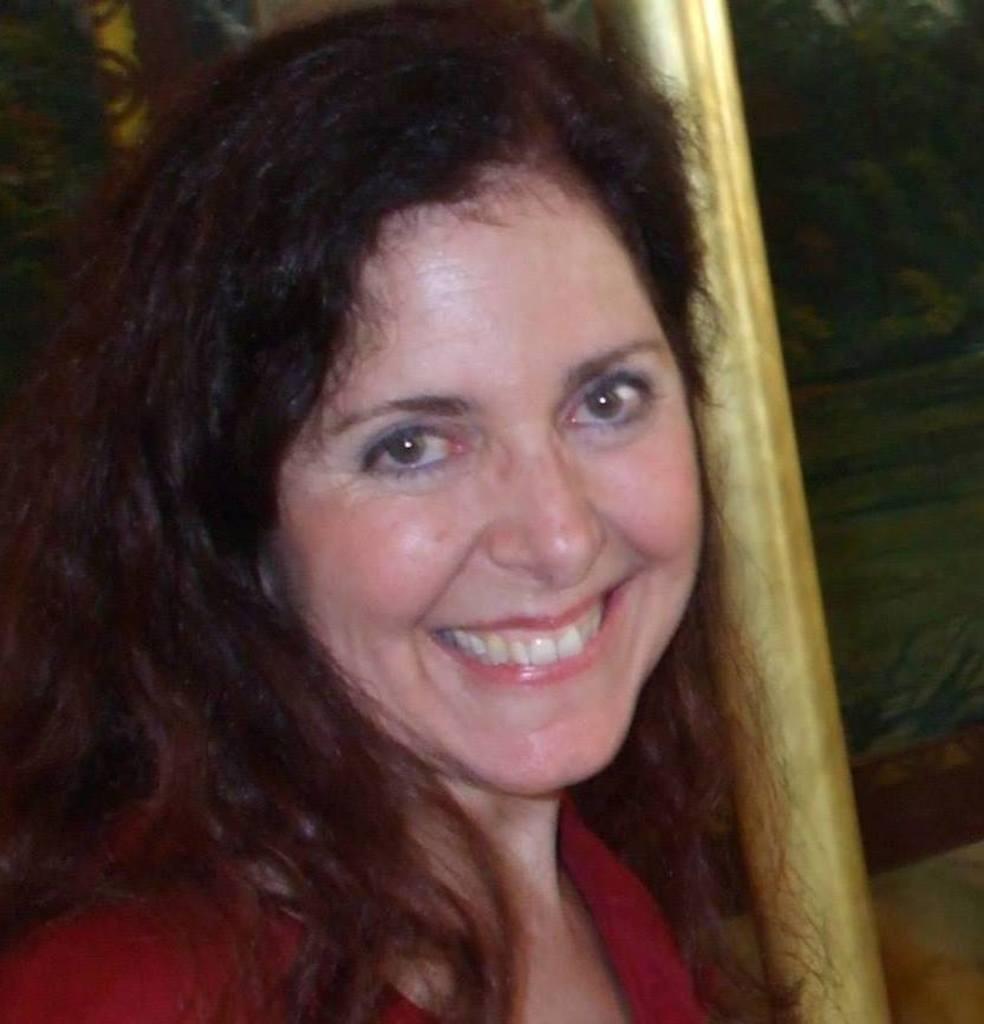Can you describe this image briefly? In this image we can see a woman. She is smiling and wearing a red color top. There is a pole on the right side of the image. It seems like a wall in the background. 